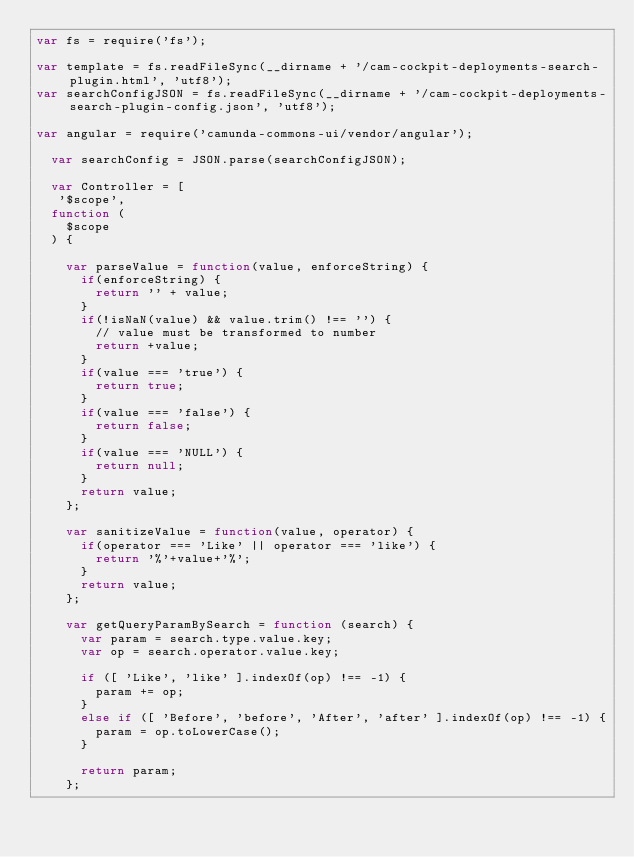Convert code to text. <code><loc_0><loc_0><loc_500><loc_500><_JavaScript_>var fs = require('fs');

var template = fs.readFileSync(__dirname + '/cam-cockpit-deployments-search-plugin.html', 'utf8');
var searchConfigJSON = fs.readFileSync(__dirname + '/cam-cockpit-deployments-search-plugin-config.json', 'utf8');

var angular = require('camunda-commons-ui/vendor/angular');

  var searchConfig = JSON.parse(searchConfigJSON);

  var Controller = [
   '$scope',
  function (
    $scope
  ) {

    var parseValue = function(value, enforceString) {
      if(enforceString) {
        return '' + value;
      }
      if(!isNaN(value) && value.trim() !== '') {
        // value must be transformed to number
        return +value;
      }
      if(value === 'true') {
        return true;
      }
      if(value === 'false') {
        return false;
      }
      if(value === 'NULL') {
        return null;
      }
      return value;
    };

    var sanitizeValue = function(value, operator) {
      if(operator === 'Like' || operator === 'like') {
        return '%'+value+'%';
      }
      return value;
    };

    var getQueryParamBySearch = function (search) {
      var param = search.type.value.key;
      var op = search.operator.value.key;

      if ([ 'Like', 'like' ].indexOf(op) !== -1) {
        param += op;
      }
      else if ([ 'Before', 'before', 'After', 'after' ].indexOf(op) !== -1) {
        param = op.toLowerCase();
      }

      return param;
    };
</code> 